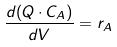Convert formula to latex. <formula><loc_0><loc_0><loc_500><loc_500>\frac { d ( Q \cdot C _ { A } ) } { d V } = r _ { A }</formula> 